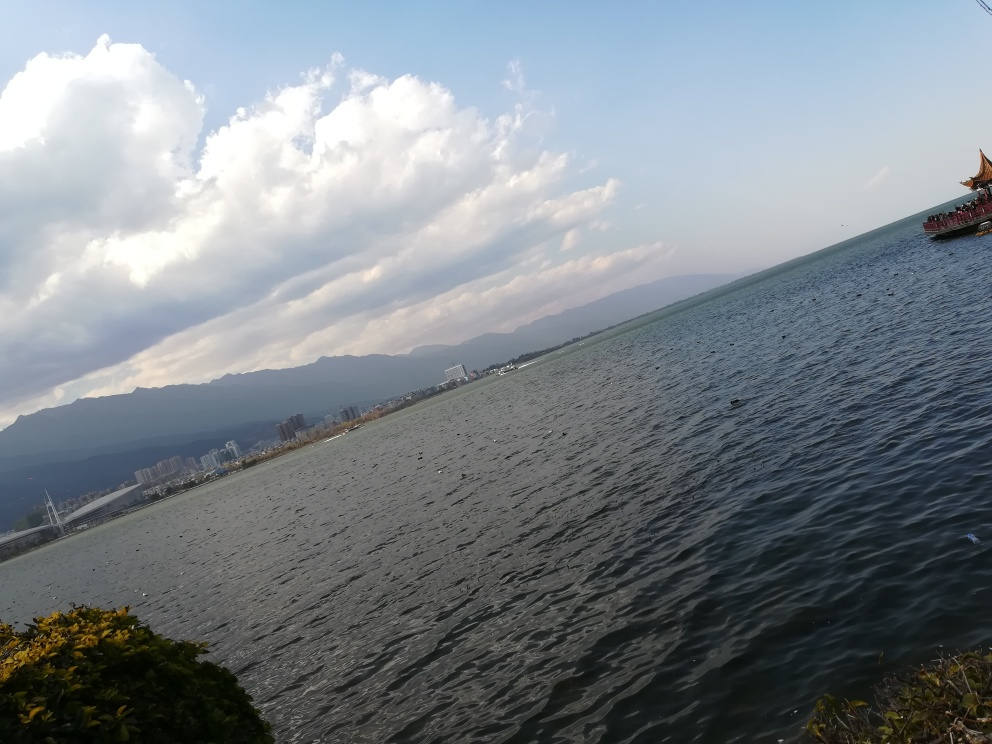Can you guess what time of day this photo was taken? Based on the long shadows and the soft, golden hue on the water, it appears to be late afternoon, possibly approaching evening. 